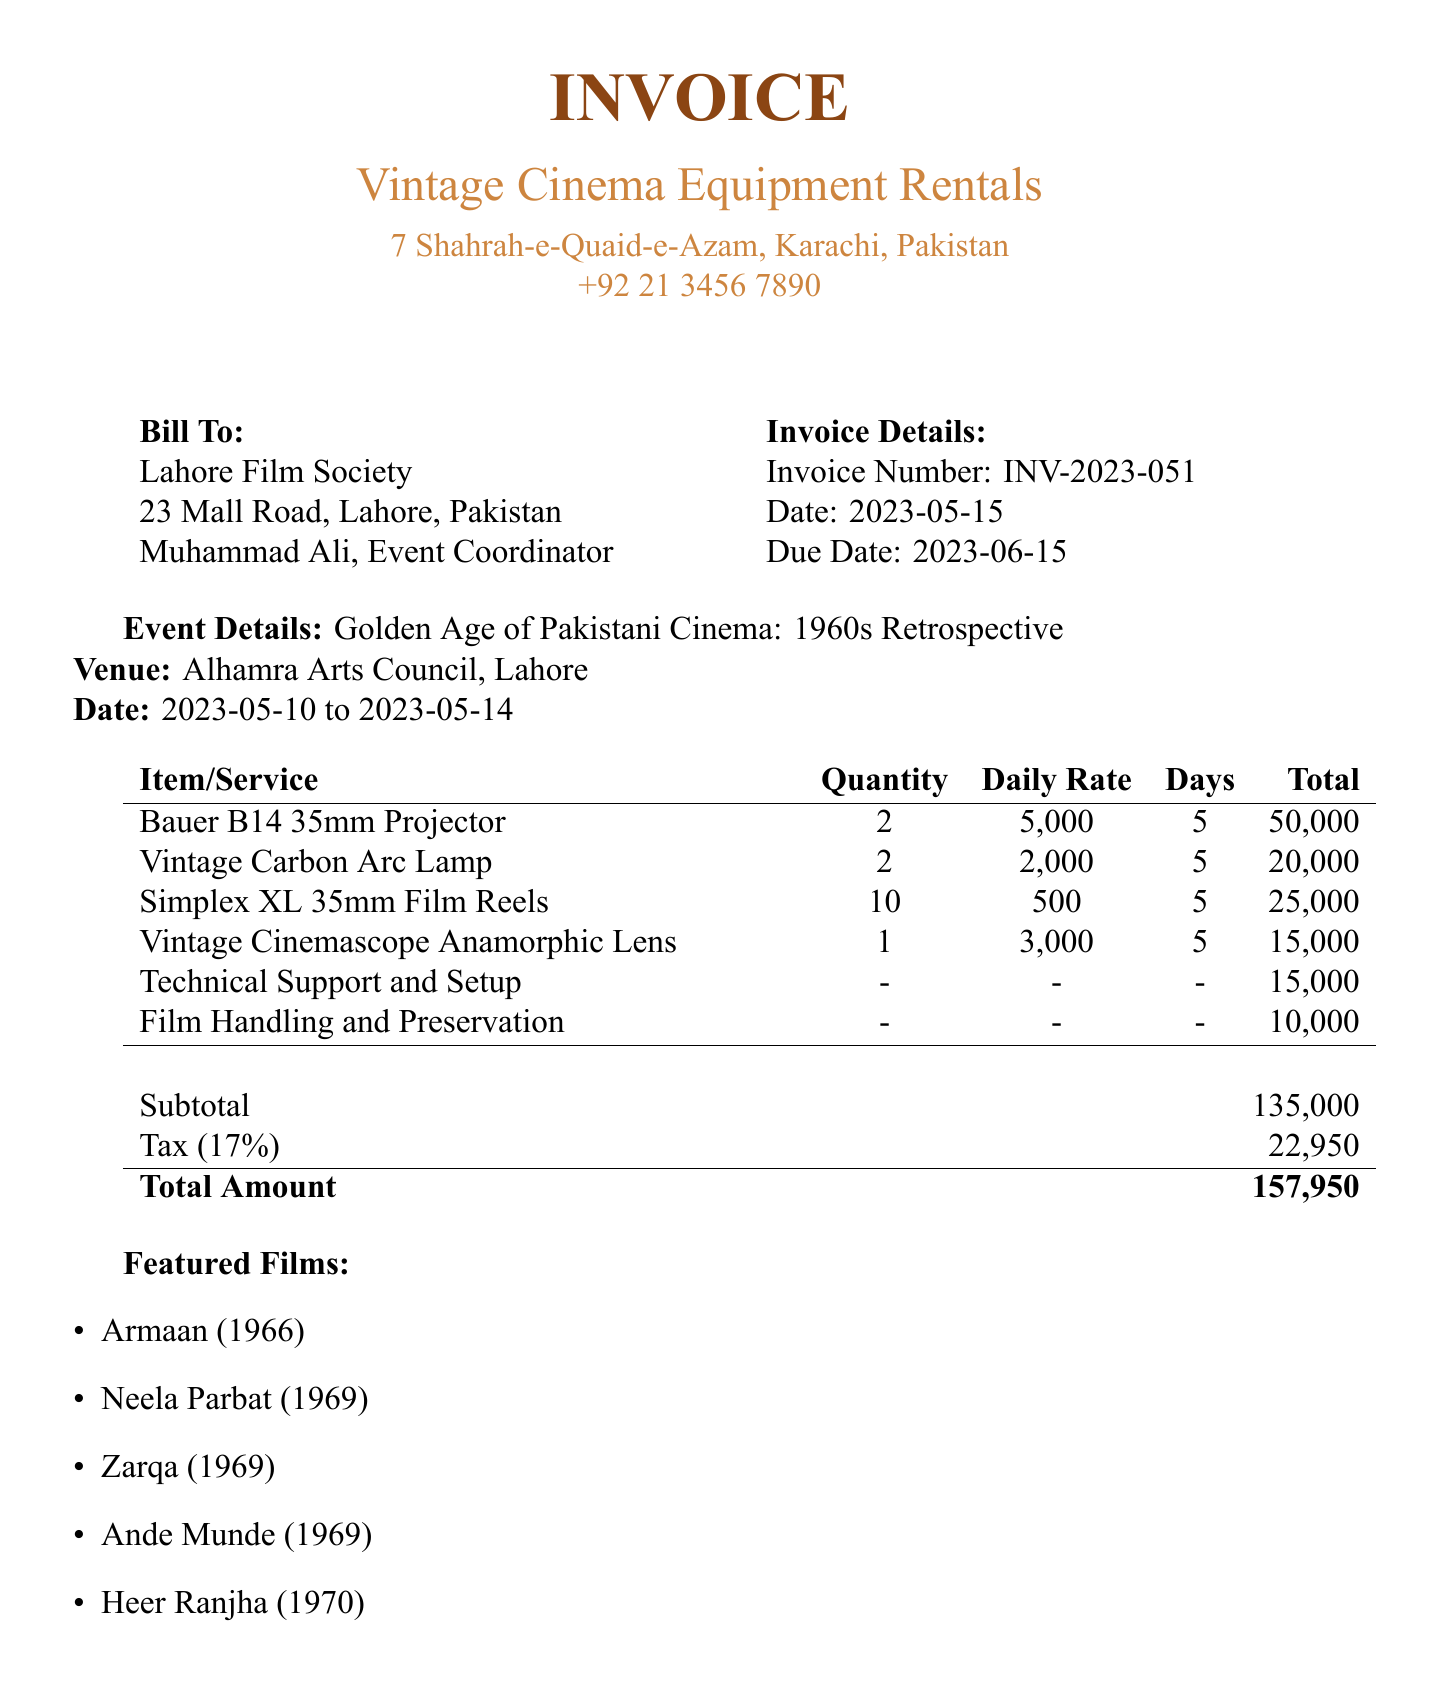What is the invoice number? The invoice number is listed clearly in the document, which is INV-2023-051.
Answer: INV-2023-051 Who is the event coordinator? The name of the event coordinator is mentioned in the billing section of the document as Muhammad Ali.
Answer: Muhammad Ali What is the total amount due? The total amount due can be found in the summary of the invoice, which states the total is 157,950.
Answer: 157,950 How many Bauer B14 35mm Projectors were rented? The document specifies that 2 Bauer B14 35mm Projectors were rented.
Answer: 2 What is the daily rate for the Vintage Carbon Arc Lamp? The daily rate for the Vintage Carbon Arc Lamp is provided in the details of the rented equipment, which is 2,000.
Answer: 2,000 What is the due date for the payment? The due date for the payment is mentioned clearly in the invoice as 2023-06-15.
Answer: 2023-06-15 What service is provided for film handling? The document lists Film Handling and Preservation as a service provided for handling delicate 1960s film reels.
Answer: Film Handling and Preservation How many days was the equipment rented for? The rental duration for all equipment is stated as 5 days in the invoice details.
Answer: 5 days What bank is used for the payment? The name of the bank where the payment should be made is mentioned as Habib Bank Limited.
Answer: Habib Bank Limited 